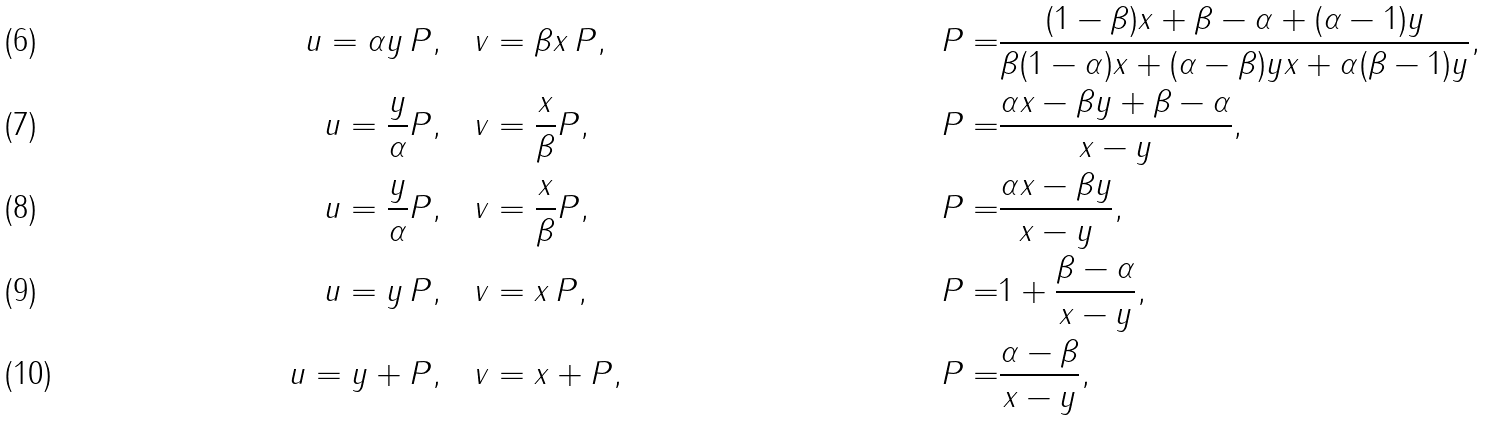Convert formula to latex. <formula><loc_0><loc_0><loc_500><loc_500>u = \alpha y \, P , \quad & v = \beta x \, P , \quad & P = & \frac { ( 1 - \beta ) x + \beta - \alpha + ( \alpha - 1 ) y } { \beta ( 1 - \alpha ) x + ( \alpha - \beta ) y x + \alpha ( \beta - 1 ) y } , \\ u = \frac { y } { \alpha } P , \quad & v = \frac { x } { \beta } P , \quad & P = & \frac { \alpha x - \beta y + \beta - \alpha } { x - y } , \\ u = \frac { y } { \alpha } P , \quad & v = \frac { x } { \beta } P , \quad & P = & \frac { \alpha x - \beta y } { x - y } , \\ u = y \, P , \quad & v = x \, P , \quad & P = & 1 + \frac { \beta - \alpha } { x - y } , \\ u = y + P , \quad & v = x + P , \quad & P = & \frac { \alpha - \beta } { x - y } ,</formula> 